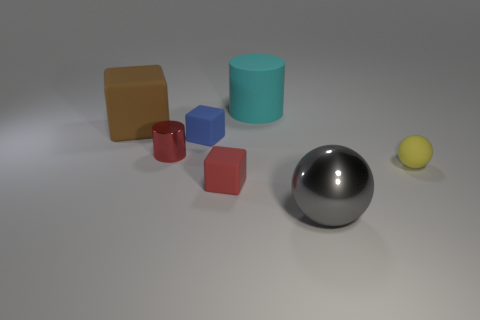How do the colors of the objects in the image work together? The colors of the objects maintain a harmonious balance, with the use of primary and secondary colors providing visual interest without overwhelming the observer. The cool blue and teal contrast pleasantly with the warm hues of the yellow and beige, while the red and pink create a softer, more pastel complement. This contrast is unified by the neutral gray of the sphere, which acts as a central point of equilibrium in the composition. 